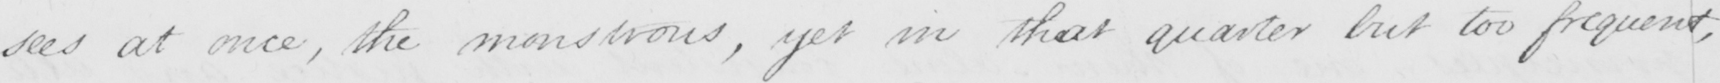Please transcribe the handwritten text in this image. sees at once , the monstrous , yet in that quarter but too frequent , 